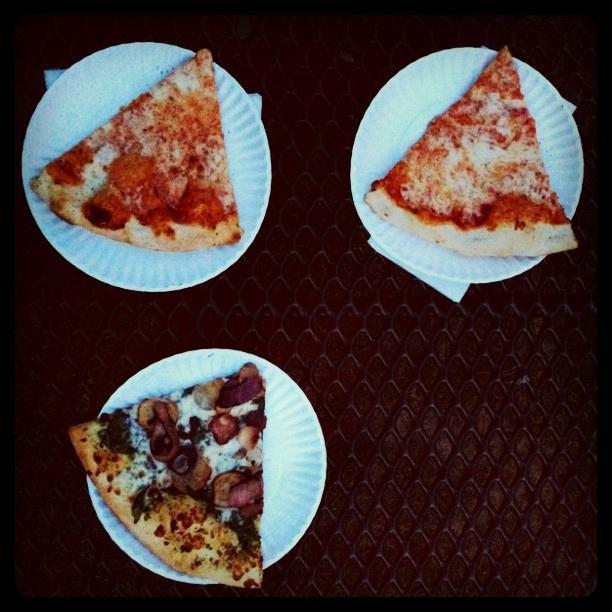How many plate are there?
Give a very brief answer. 3. How many slices?
Give a very brief answer. 3. How many pizzas are there?
Give a very brief answer. 3. 